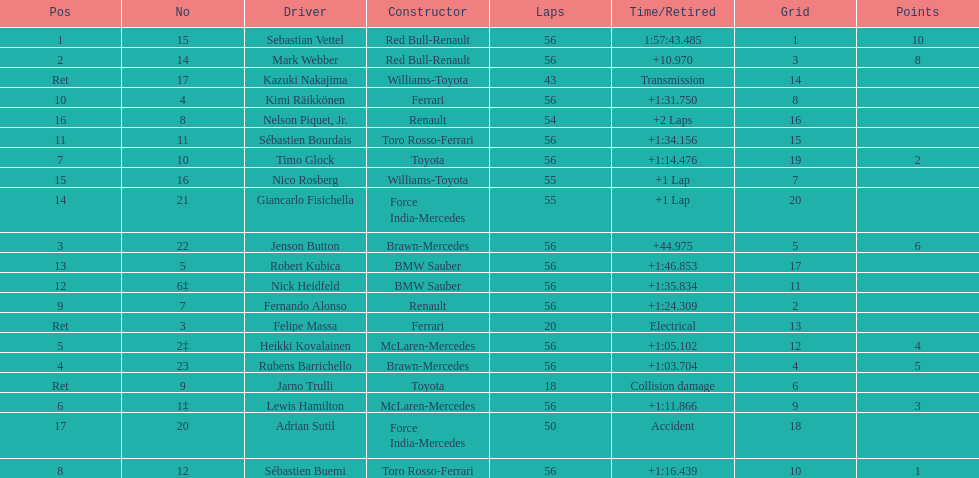What is the total number of drivers on the list? 20. 